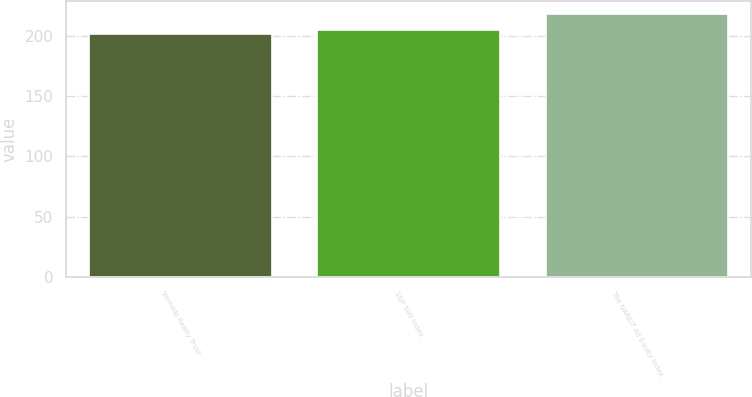Convert chart. <chart><loc_0><loc_0><loc_500><loc_500><bar_chart><fcel>Vornado Realty Trust<fcel>S&P 500 Index<fcel>The NAREIT All Equity Index<nl><fcel>201<fcel>205<fcel>218<nl></chart> 